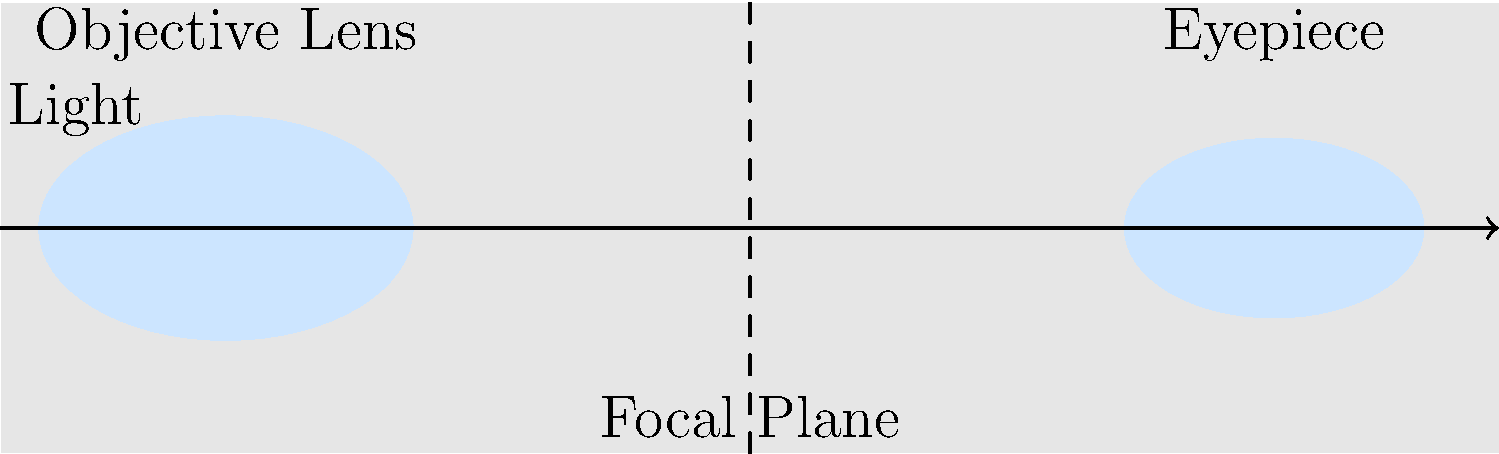In the labeled cross-section of a refracting telescope shown above, which component is responsible for gathering and focusing the initial light from distant objects, and how does this relate to the telescope's ability to magnify images? To answer this question, let's break down the components and their functions in a refracting telescope:

1. The objective lens, located at the front of the telescope (left side in the diagram), is the primary light-gathering element.

2. Its main functions are:
   a) To collect light from distant objects
   b) To focus this light to form an image at the focal plane

3. The size of the objective lens determines the telescope's light-gathering power. A larger objective lens can collect more light, allowing for observation of fainter objects.

4. The focal length of the objective lens (distance from the lens to the focal plane) affects the telescope's magnification when combined with the eyepiece.

5. The eyepiece, located at the back of the telescope (right side in the diagram), is used to magnify the image formed by the objective lens.

6. The magnification of a telescope is calculated by dividing the focal length of the objective lens by the focal length of the eyepiece.

7. Therefore, the objective lens plays a crucial role in both light gathering and determining the potential magnification of the telescope.

In the context of financial planning, this system can be likened to gathering and focusing resources (light) to achieve long-term goals (clear image), with the initial investment (objective lens) setting the foundation for potential growth (magnification).
Answer: Objective lens; it gathers light and determines potential magnification. 